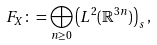<formula> <loc_0><loc_0><loc_500><loc_500>\ F _ { X } \colon = \bigoplus _ { n \geq 0 } \left ( L ^ { 2 } ( \mathbb { R } ^ { 3 n } ) \right ) _ { s } ,</formula> 